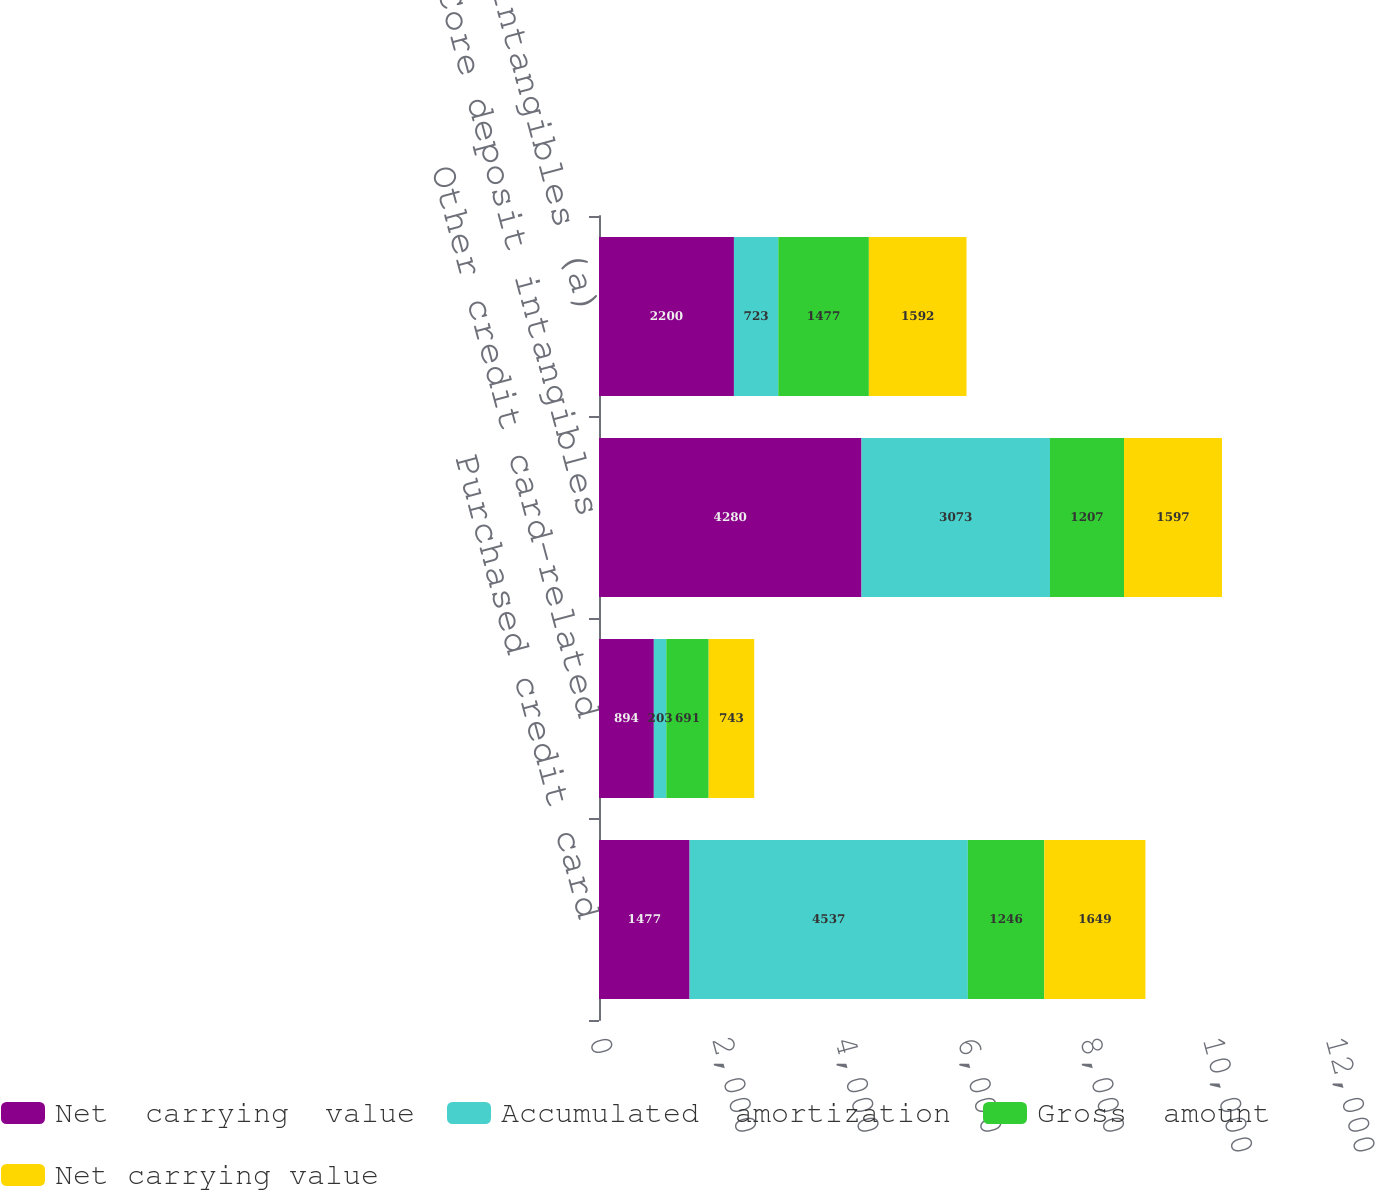<chart> <loc_0><loc_0><loc_500><loc_500><stacked_bar_chart><ecel><fcel>Purchased credit card<fcel>Other credit card-related<fcel>Core deposit intangibles<fcel>Other intangibles (a)<nl><fcel>Net  carrying  value<fcel>1477<fcel>894<fcel>4280<fcel>2200<nl><fcel>Accumulated  amortization<fcel>4537<fcel>203<fcel>3073<fcel>723<nl><fcel>Gross  amount<fcel>1246<fcel>691<fcel>1207<fcel>1477<nl><fcel>Net carrying value<fcel>1649<fcel>743<fcel>1597<fcel>1592<nl></chart> 